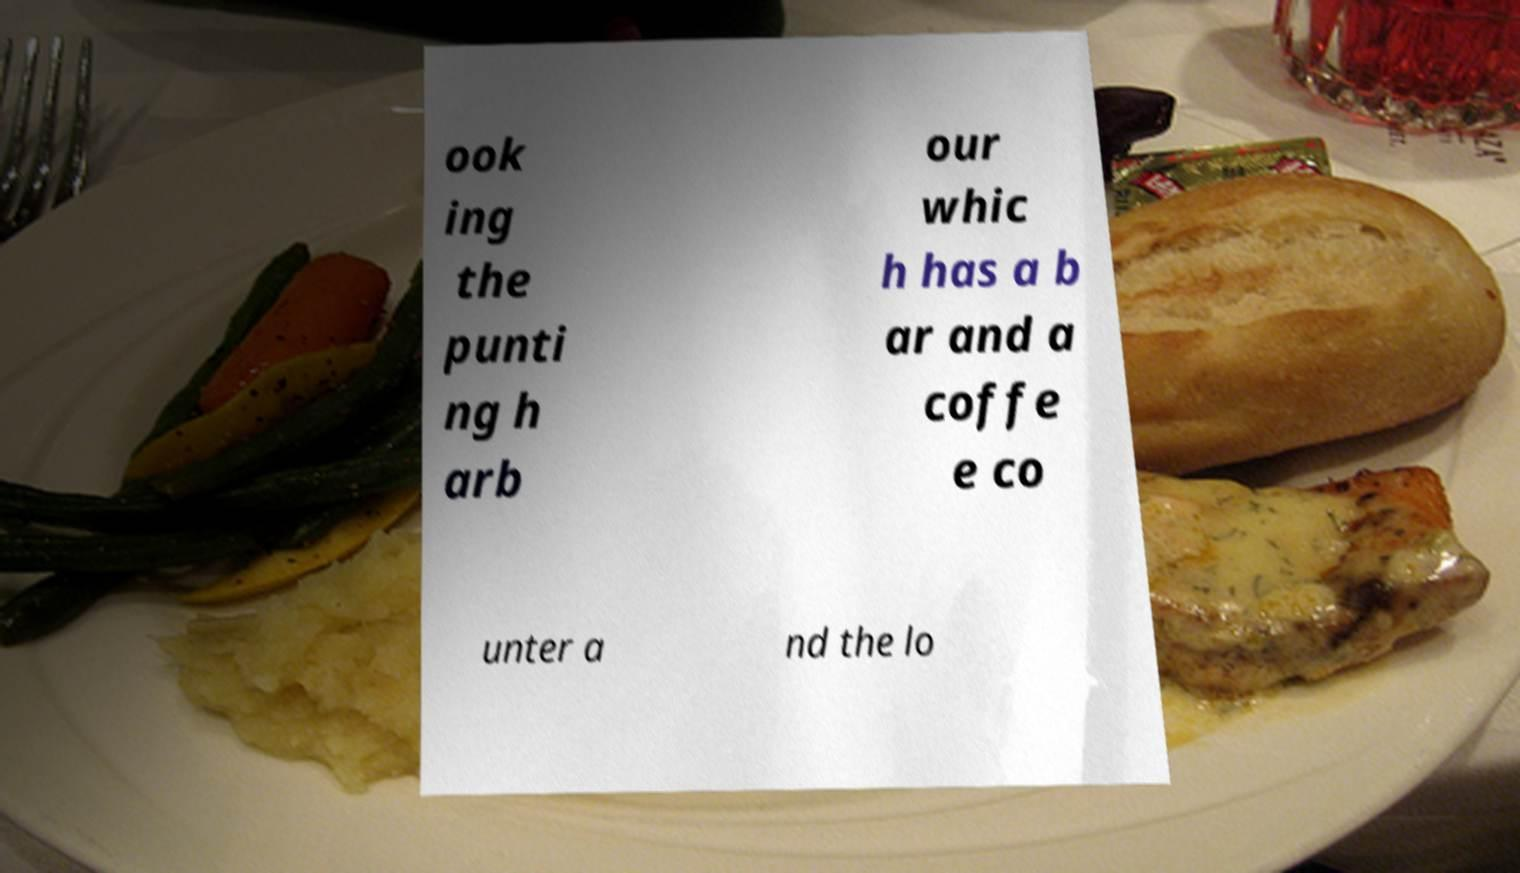For documentation purposes, I need the text within this image transcribed. Could you provide that? ook ing the punti ng h arb our whic h has a b ar and a coffe e co unter a nd the lo 